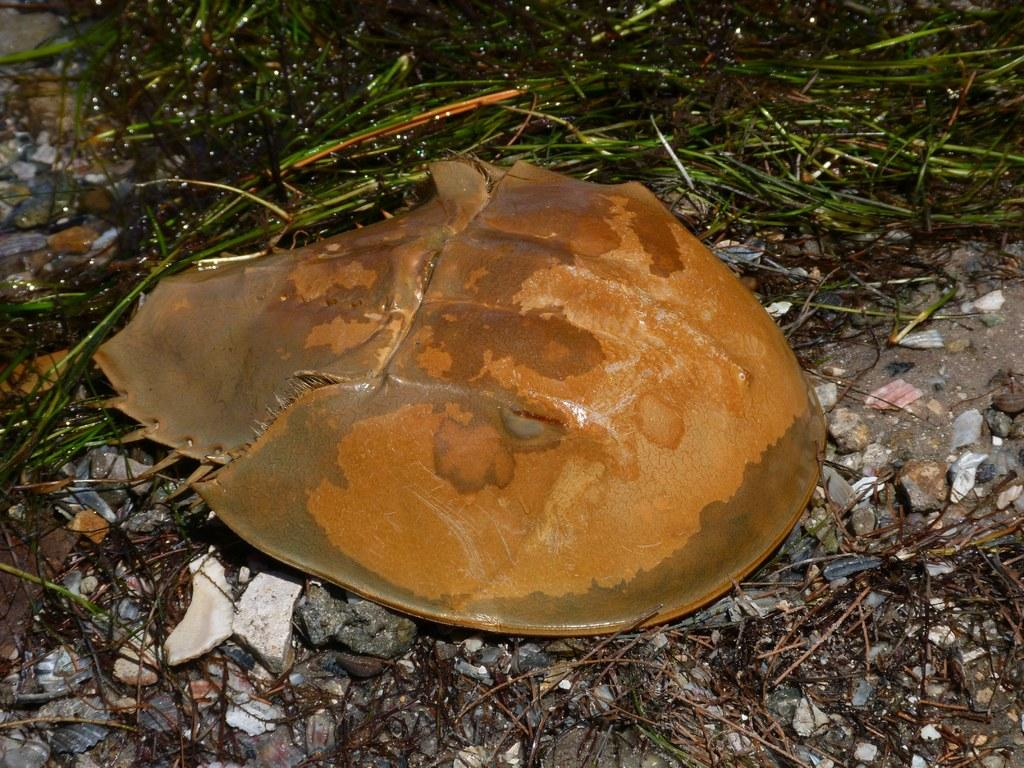What is the color of the object on the floor in the image? The object on the floor is grey. What type of surface can be seen in the image? Soil is visible in the image. What type of vegetation is present in the image? There is grass in the image. What other natural elements can be seen in the image? There are twigs in the image. Can you see any ghosts in the image? No, there are no ghosts present in the image. Is there any steam visible in the image? No, there is no steam visible in the image. 